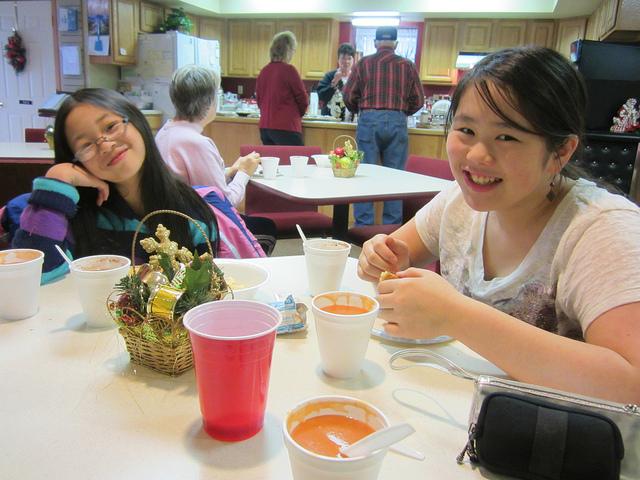Where are the polka dots?
Write a very short answer. Nowhere. What kind of cup is the red cup?
Keep it brief. Plastic. How many people are there?
Write a very short answer. 6. Could the girls be sisters?
Be succinct. Yes. 